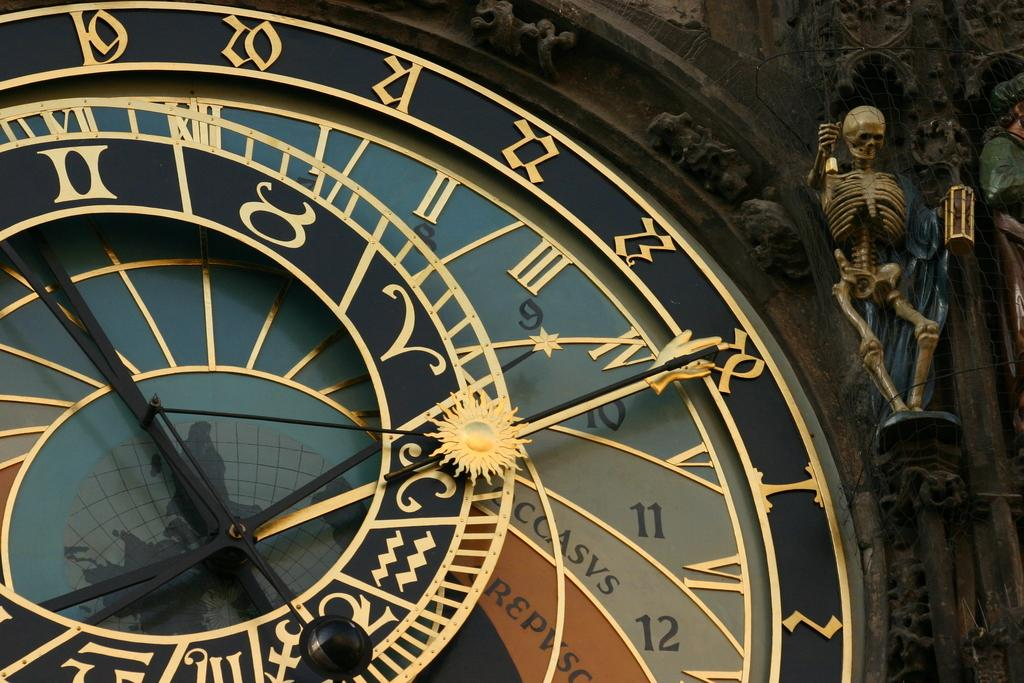Provide a one-sentence caption for the provided image. Number 19 through 28, and numbers one and two are seen on a clock, with a skeleton hanging to the top, right corner of it. 